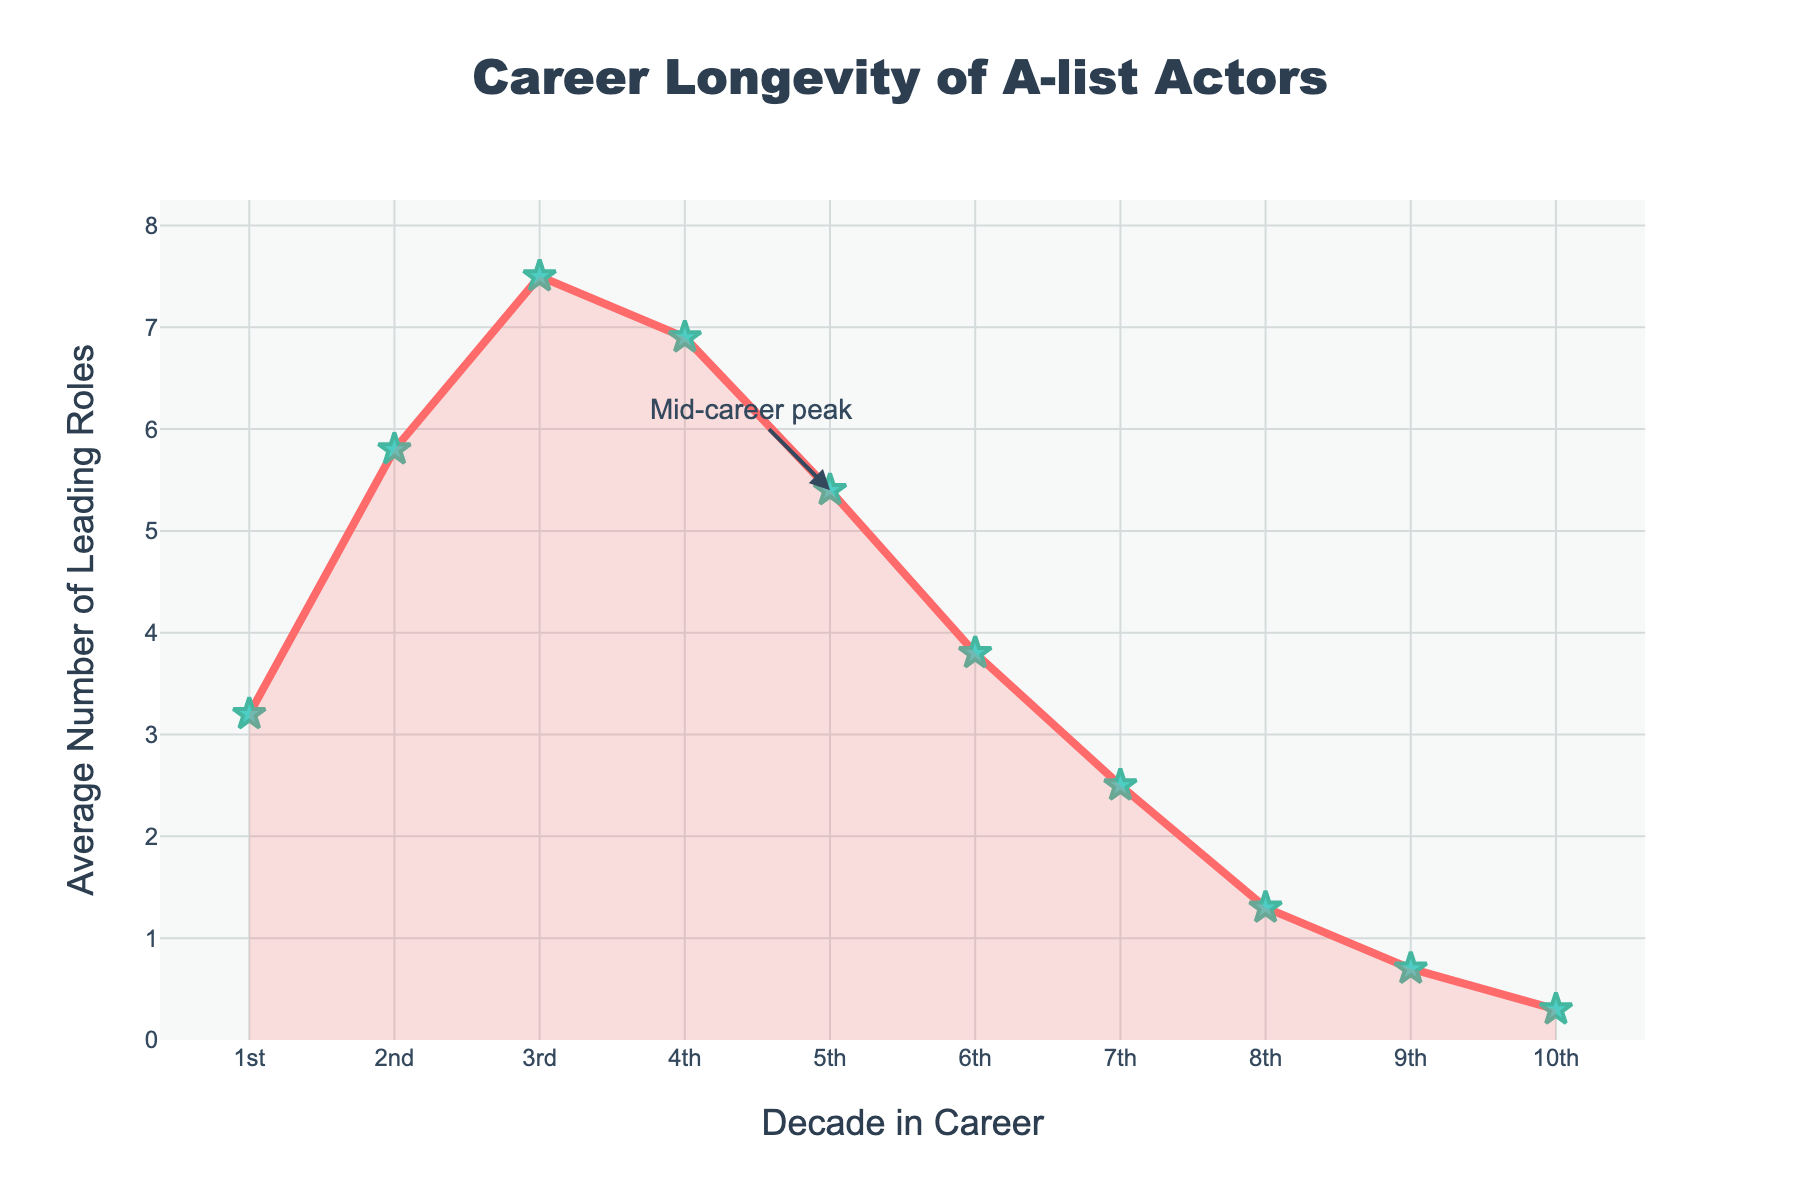Which decade has the highest average number of leading roles? Look at the plotted data points to identify which decade shows the peak. The highest point is in the 3rd decade with an average of 7.5 leading roles.
Answer: 3rd decade What is the difference in the average number of leading roles between the 3rd and 8th decades? Identify the average leading roles for the 3rd (7.5) and 8th (1.3) decades. Subtract 1.3 from 7.5 to get the difference.
Answer: 6.2 In which decade does the average number of leading roles start to decrease after reaching its peak? Observe the chart to see the point at which the average starts declining after the highest value in the 3rd decade (7.5 in the 3rd decade, then 6.9 in the 4th decade).
Answer: 4th decade How does the average number of leading roles in the 6th decade compare to the 5th decade? Look at the plotted values for the 5th (5.4) and 6th (3.8) decades and compare them. The 6th decade has fewer leading roles.
Answer: 6th is less What is the percentage decrease in the average number of leading roles from the 4th to the 10th decade? The average in the 4th decade is 6.9 and in the 10th decade it is 0.3. Calculate the percentage decrease: ((6.9 - 0.3) / 6.9) * 100.
Answer: 95.65% Which visual element highlights the mid-career peak in the chart? Look for annotations or specific features that denote key points on the graph. There is an annotation with the text "Mid-career peak" highlighting the 5th decade.
Answer: Annotation From the 2nd decade to the 7th decade, by how much does the average number of leading roles decline? Identify the values for these decades: 2nd (5.8) and 7th (2.5). Subtract 2.5 from 5.8 to find the decline.
Answer: 3.3 What is the total average number of leading roles across the first four decades? Add the values for each of the first four decades: 3.2 + 5.8 + 7.5 + 6.9. The sum gives the total average.
Answer: 23.4 